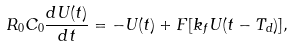<formula> <loc_0><loc_0><loc_500><loc_500>R _ { 0 } C _ { 0 } \frac { d U ( t ) } { d t } = - U ( t ) + F [ k _ { f } U ( t - T _ { d } ) ] ,</formula> 